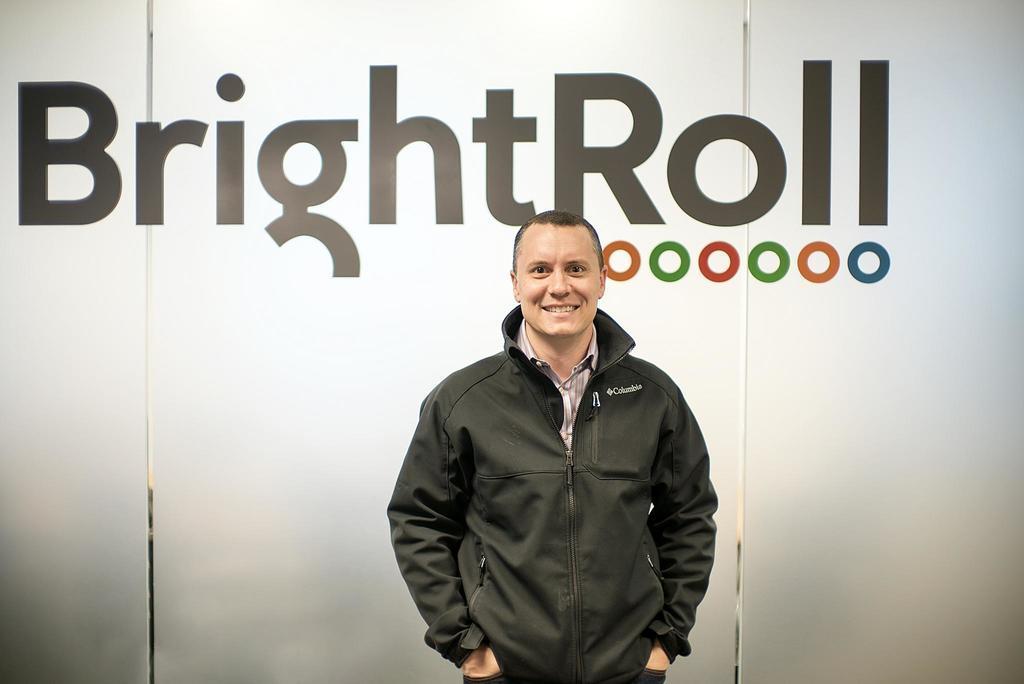Could you give a brief overview of what you see in this image? In the foreground I can see a person is standing on the floor in front of a wall and a text. This image is taken may be in a hall. 